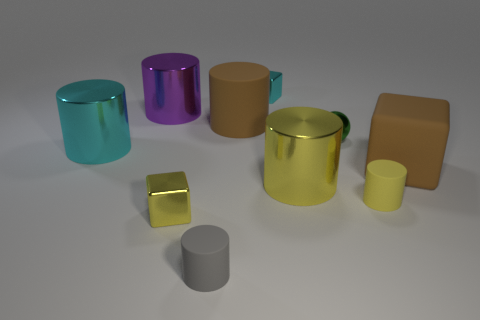Subtract 1 cubes. How many cubes are left? 2 Subtract all cyan metal cylinders. How many cylinders are left? 5 Subtract all brown balls. How many yellow cylinders are left? 2 Subtract all purple cylinders. How many cylinders are left? 5 Subtract all yellow cylinders. Subtract all cyan spheres. How many cylinders are left? 4 Subtract all balls. How many objects are left? 9 Subtract all green cylinders. Subtract all brown cubes. How many objects are left? 9 Add 3 green shiny balls. How many green shiny balls are left? 4 Add 2 yellow rubber objects. How many yellow rubber objects exist? 3 Subtract 0 gray spheres. How many objects are left? 10 